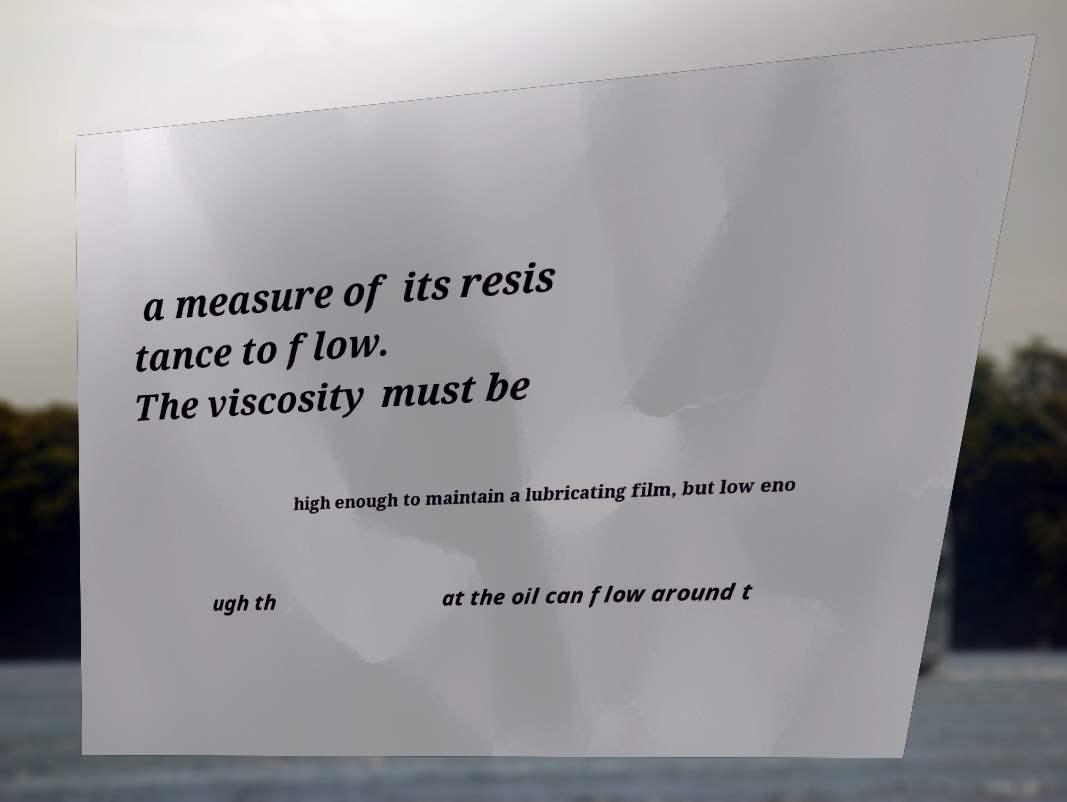What messages or text are displayed in this image? I need them in a readable, typed format. a measure of its resis tance to flow. The viscosity must be high enough to maintain a lubricating film, but low eno ugh th at the oil can flow around t 